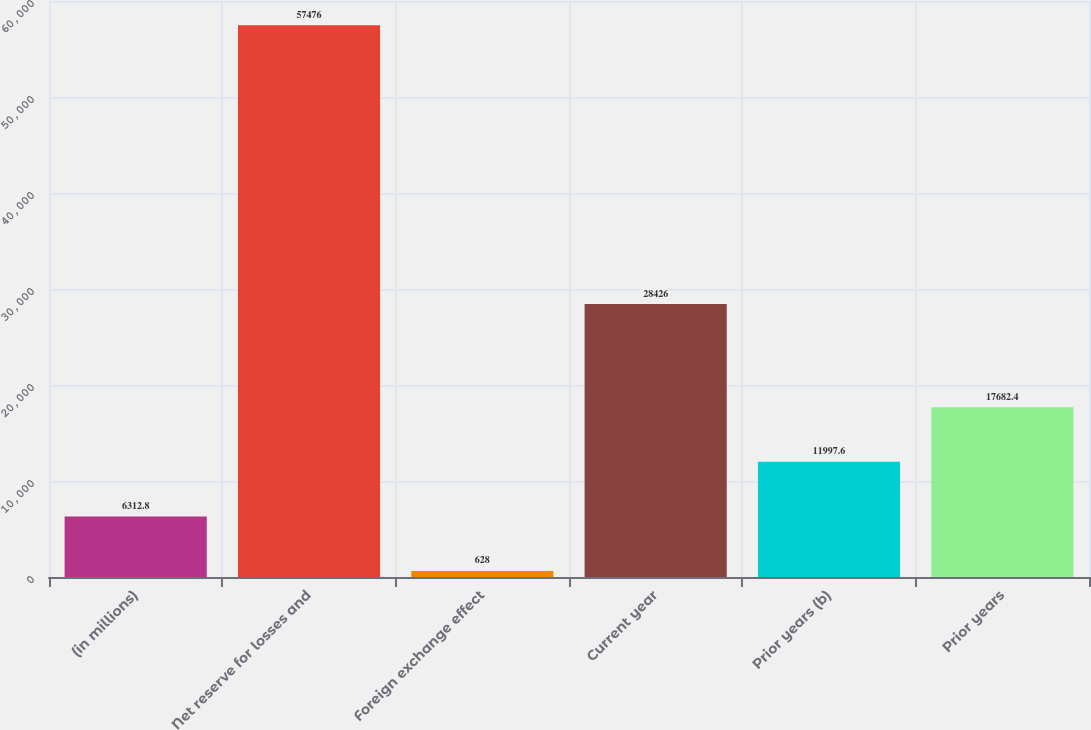Convert chart to OTSL. <chart><loc_0><loc_0><loc_500><loc_500><bar_chart><fcel>(in millions)<fcel>Net reserve for losses and<fcel>Foreign exchange effect<fcel>Current year<fcel>Prior years (b)<fcel>Prior years<nl><fcel>6312.8<fcel>57476<fcel>628<fcel>28426<fcel>11997.6<fcel>17682.4<nl></chart> 